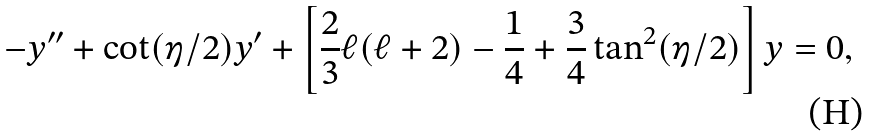Convert formula to latex. <formula><loc_0><loc_0><loc_500><loc_500>- y ^ { \prime \prime } + \cot ( \eta / 2 ) y ^ { \prime } + \left [ \frac { 2 } { 3 } \ell ( \ell + 2 ) - \frac { 1 } { 4 } + \frac { 3 } { 4 } \tan ^ { 2 } ( \eta / 2 ) \right ] y = 0 ,</formula> 